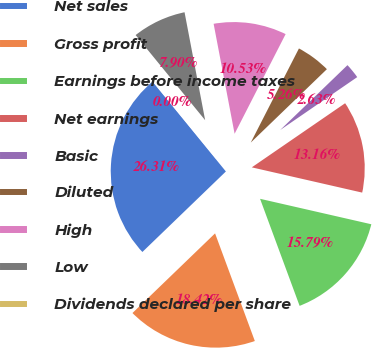Convert chart to OTSL. <chart><loc_0><loc_0><loc_500><loc_500><pie_chart><fcel>Net sales<fcel>Gross profit<fcel>Earnings before income taxes<fcel>Net earnings<fcel>Basic<fcel>Diluted<fcel>High<fcel>Low<fcel>Dividends declared per share<nl><fcel>26.31%<fcel>18.42%<fcel>15.79%<fcel>13.16%<fcel>2.63%<fcel>5.26%<fcel>10.53%<fcel>7.9%<fcel>0.0%<nl></chart> 